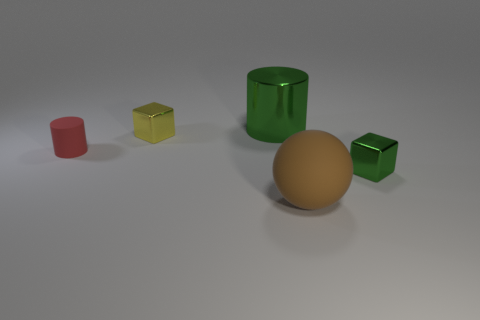Add 1 red cylinders. How many objects exist? 6 Subtract all cylinders. How many objects are left? 3 Subtract all small green objects. Subtract all metallic things. How many objects are left? 1 Add 2 big shiny cylinders. How many big shiny cylinders are left? 3 Add 4 big objects. How many big objects exist? 6 Subtract 0 cyan spheres. How many objects are left? 5 